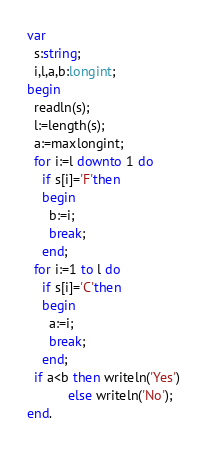<code> <loc_0><loc_0><loc_500><loc_500><_Pascal_>var
  s:string;
  i,l,a,b:longint; 
begin
  readln(s);
  l:=length(s);
  a:=maxlongint; 
  for i:=l downto 1 do 
    if s[i]='F'then 
    begin
      b:=i;
      break;
    end;
  for i:=1 to l do 
    if s[i]='C'then 
    begin
      a:=i;
      break;
    end;
  if a<b then writeln('Yes')
           else writeln('No'); 
end.</code> 